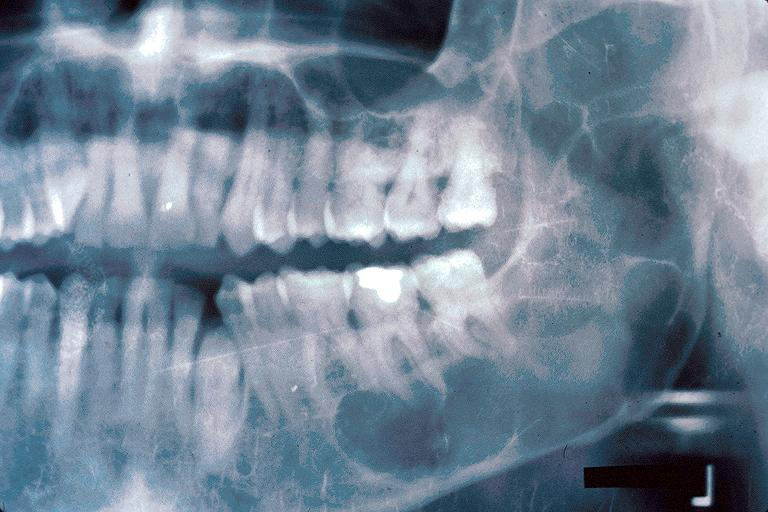does gram show odontogenic keratocyst?
Answer the question using a single word or phrase. No 